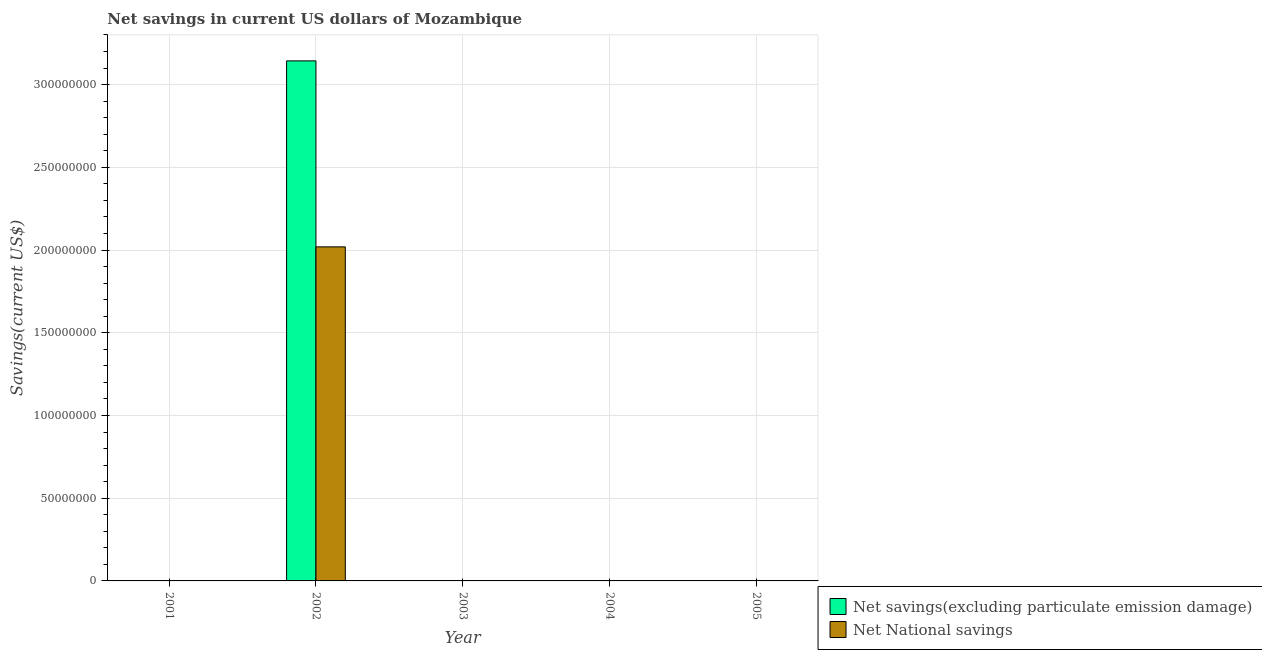How many different coloured bars are there?
Provide a short and direct response. 2. Are the number of bars per tick equal to the number of legend labels?
Offer a very short reply. No. Are the number of bars on each tick of the X-axis equal?
Offer a very short reply. No. How many bars are there on the 4th tick from the left?
Your answer should be very brief. 0. In how many cases, is the number of bars for a given year not equal to the number of legend labels?
Your answer should be very brief. 4. What is the net national savings in 2002?
Make the answer very short. 2.02e+08. Across all years, what is the maximum net national savings?
Your answer should be very brief. 2.02e+08. Across all years, what is the minimum net national savings?
Offer a terse response. 0. In which year was the net national savings maximum?
Your answer should be compact. 2002. What is the total net national savings in the graph?
Make the answer very short. 2.02e+08. What is the average net savings(excluding particulate emission damage) per year?
Offer a very short reply. 6.29e+07. In the year 2002, what is the difference between the net savings(excluding particulate emission damage) and net national savings?
Offer a very short reply. 0. What is the difference between the highest and the lowest net national savings?
Ensure brevity in your answer.  2.02e+08. How many bars are there?
Your answer should be compact. 2. How many years are there in the graph?
Ensure brevity in your answer.  5. What is the difference between two consecutive major ticks on the Y-axis?
Keep it short and to the point. 5.00e+07. Are the values on the major ticks of Y-axis written in scientific E-notation?
Offer a terse response. No. Does the graph contain any zero values?
Offer a very short reply. Yes. Does the graph contain grids?
Make the answer very short. Yes. Where does the legend appear in the graph?
Keep it short and to the point. Bottom right. How are the legend labels stacked?
Make the answer very short. Vertical. What is the title of the graph?
Ensure brevity in your answer.  Net savings in current US dollars of Mozambique. Does "Urban" appear as one of the legend labels in the graph?
Offer a very short reply. No. What is the label or title of the Y-axis?
Offer a very short reply. Savings(current US$). What is the Savings(current US$) of Net National savings in 2001?
Offer a very short reply. 0. What is the Savings(current US$) of Net savings(excluding particulate emission damage) in 2002?
Ensure brevity in your answer.  3.14e+08. What is the Savings(current US$) of Net National savings in 2002?
Your answer should be compact. 2.02e+08. What is the Savings(current US$) of Net savings(excluding particulate emission damage) in 2003?
Give a very brief answer. 0. What is the Savings(current US$) of Net National savings in 2003?
Your answer should be compact. 0. What is the Savings(current US$) in Net savings(excluding particulate emission damage) in 2004?
Your response must be concise. 0. What is the Savings(current US$) of Net savings(excluding particulate emission damage) in 2005?
Provide a succinct answer. 0. What is the Savings(current US$) in Net National savings in 2005?
Make the answer very short. 0. Across all years, what is the maximum Savings(current US$) of Net savings(excluding particulate emission damage)?
Give a very brief answer. 3.14e+08. Across all years, what is the maximum Savings(current US$) of Net National savings?
Make the answer very short. 2.02e+08. Across all years, what is the minimum Savings(current US$) in Net National savings?
Your answer should be very brief. 0. What is the total Savings(current US$) in Net savings(excluding particulate emission damage) in the graph?
Your answer should be compact. 3.14e+08. What is the total Savings(current US$) of Net National savings in the graph?
Offer a terse response. 2.02e+08. What is the average Savings(current US$) of Net savings(excluding particulate emission damage) per year?
Give a very brief answer. 6.29e+07. What is the average Savings(current US$) in Net National savings per year?
Make the answer very short. 4.04e+07. In the year 2002, what is the difference between the Savings(current US$) of Net savings(excluding particulate emission damage) and Savings(current US$) of Net National savings?
Give a very brief answer. 1.12e+08. What is the difference between the highest and the lowest Savings(current US$) in Net savings(excluding particulate emission damage)?
Offer a terse response. 3.14e+08. What is the difference between the highest and the lowest Savings(current US$) in Net National savings?
Your response must be concise. 2.02e+08. 